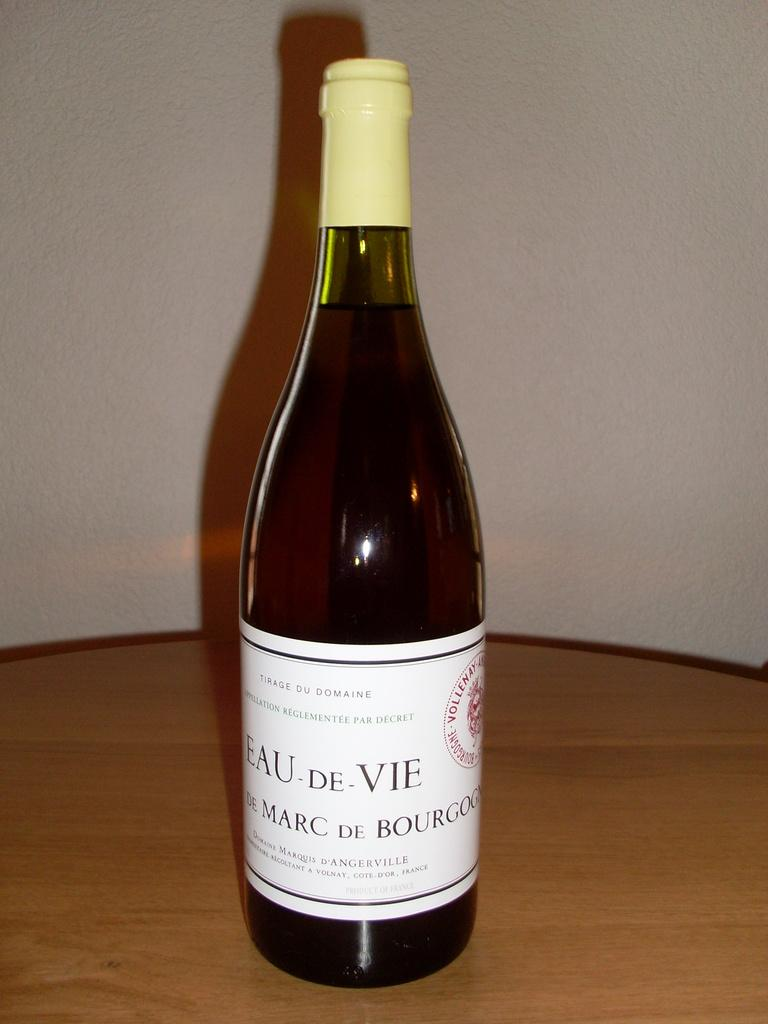<image>
Present a compact description of the photo's key features. Tall bottle with a label that says "EAU-De-VIE" on it. 